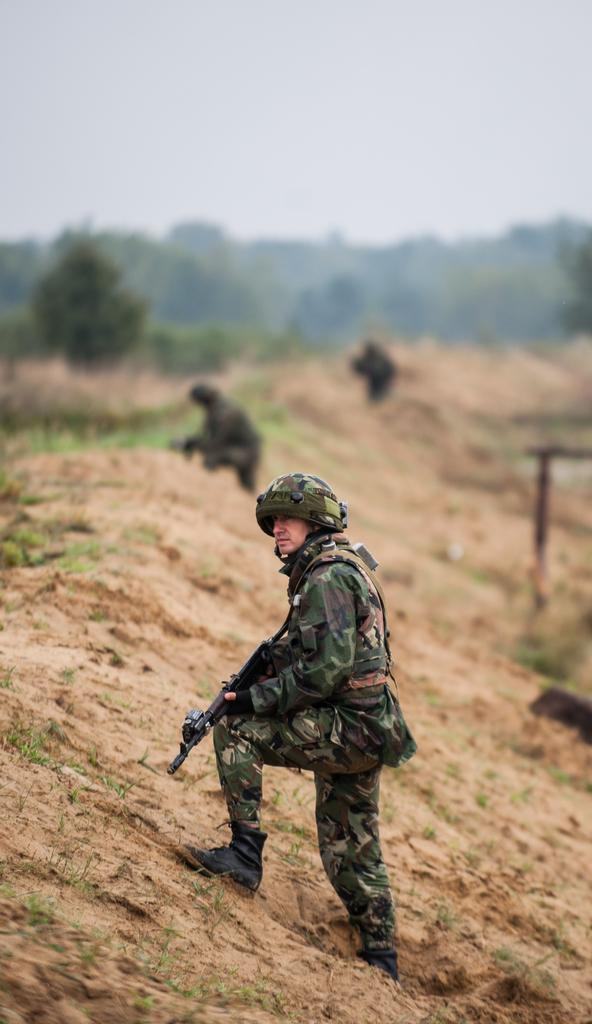What are the people in the image doing on the hill? The people in the image are standing on a hill and holding guns. What type of vegetation can be seen in the image? There is grass visible in the image. What is visible in the background of the image? There are trees and the sky visible in the background of the image. How would you describe the weather in the image? The sky appears cloudy in the image, suggesting a potentially overcast or rainy day. What type of liquid is being poured out of the tank in the image? There is no tank or liquid present in the image. How does the waste management system work in the image? There is no mention of waste or a waste management system in the image. 